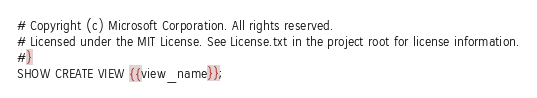Convert code to text. <code><loc_0><loc_0><loc_500><loc_500><_SQL_># Copyright (c) Microsoft Corporation. All rights reserved.
# Licensed under the MIT License. See License.txt in the project root for license information.
#}
SHOW CREATE VIEW {{view_name}};</code> 